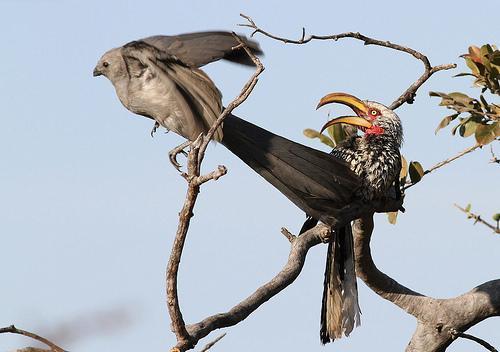How many birds are in the tree?
Give a very brief answer. 2. 